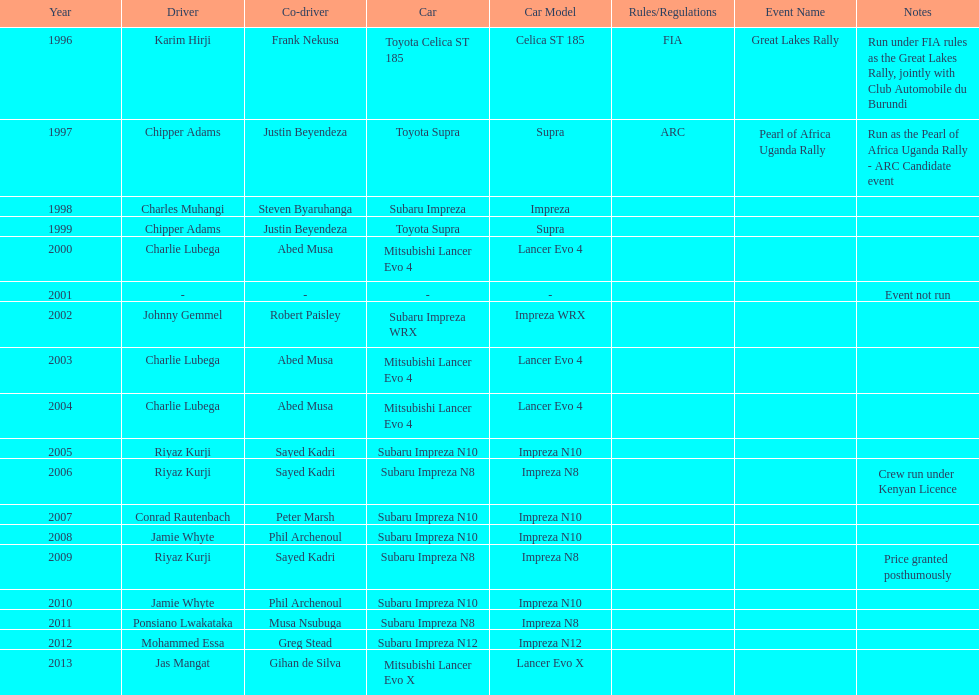How many drivers are racing with a co-driver from a different country? 1. 